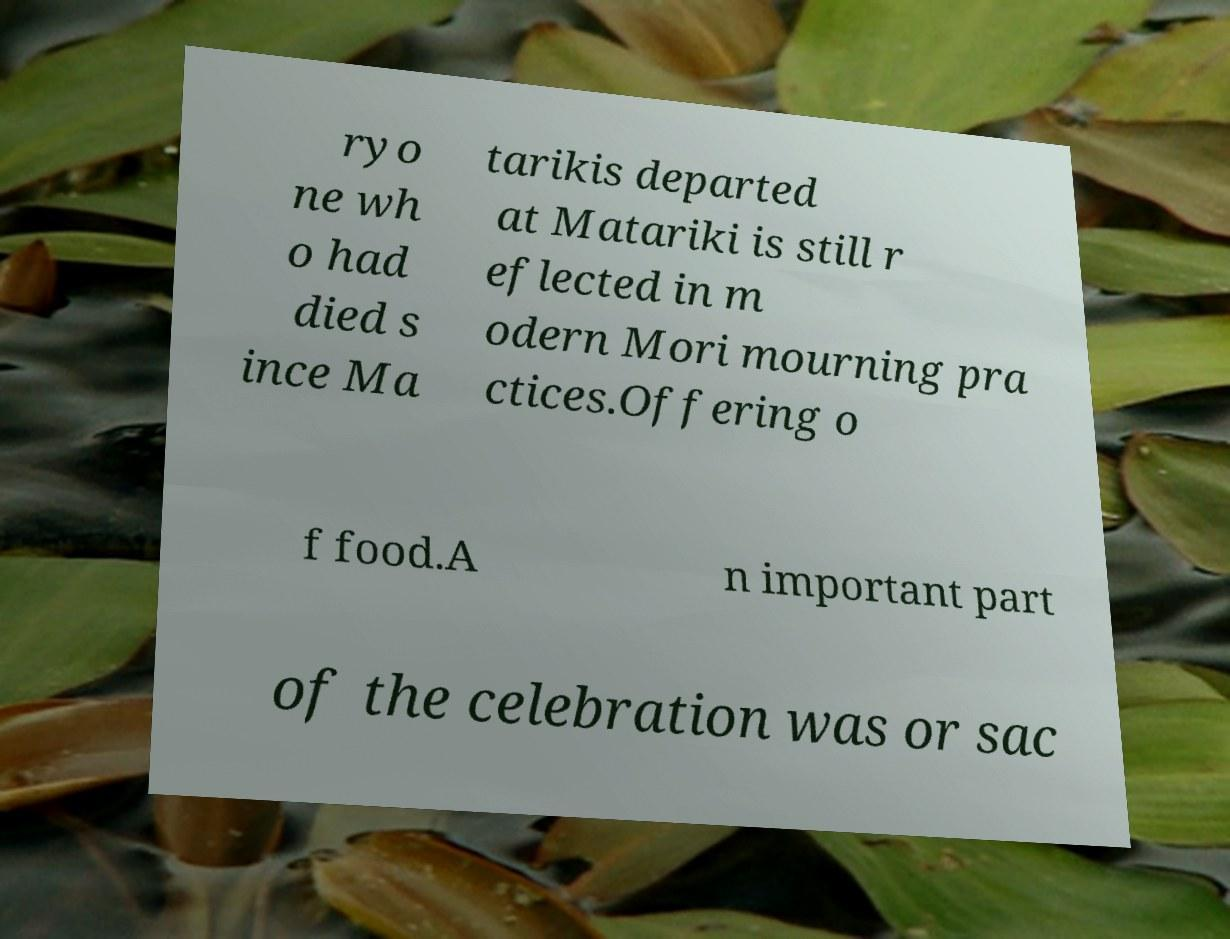Could you extract and type out the text from this image? ryo ne wh o had died s ince Ma tarikis departed at Matariki is still r eflected in m odern Mori mourning pra ctices.Offering o f food.A n important part of the celebration was or sac 